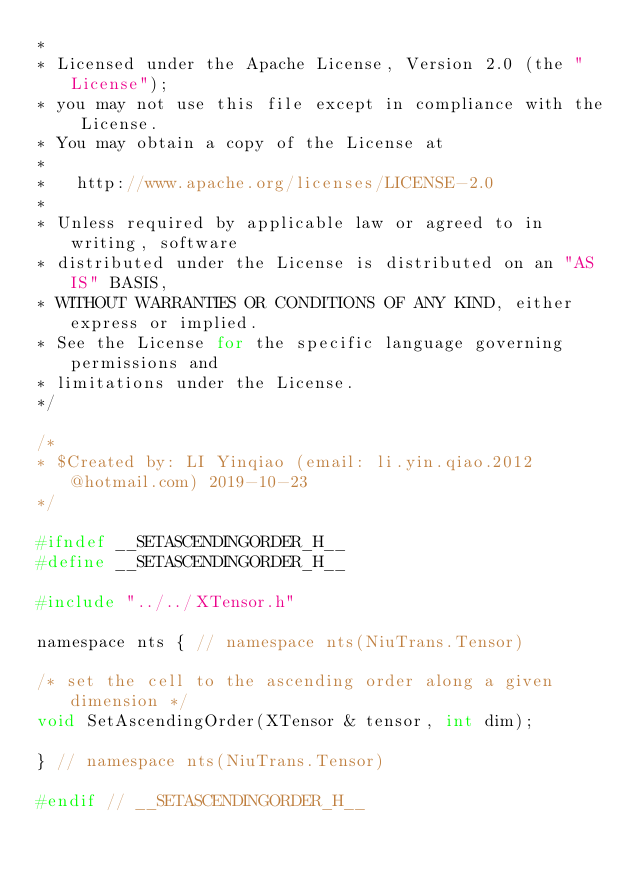<code> <loc_0><loc_0><loc_500><loc_500><_C_>*
* Licensed under the Apache License, Version 2.0 (the "License");
* you may not use this file except in compliance with the License.
* You may obtain a copy of the License at
*
*   http://www.apache.org/licenses/LICENSE-2.0
*
* Unless required by applicable law or agreed to in writing, software
* distributed under the License is distributed on an "AS IS" BASIS,
* WITHOUT WARRANTIES OR CONDITIONS OF ANY KIND, either express or implied.
* See the License for the specific language governing permissions and
* limitations under the License.
*/

/*
* $Created by: LI Yinqiao (email: li.yin.qiao.2012@hotmail.com) 2019-10-23
*/

#ifndef __SETASCENDINGORDER_H__
#define __SETASCENDINGORDER_H__

#include "../../XTensor.h"

namespace nts { // namespace nts(NiuTrans.Tensor)
    
/* set the cell to the ascending order along a given dimension */
void SetAscendingOrder(XTensor & tensor, int dim);

} // namespace nts(NiuTrans.Tensor)

#endif // __SETASCENDINGORDER_H__</code> 